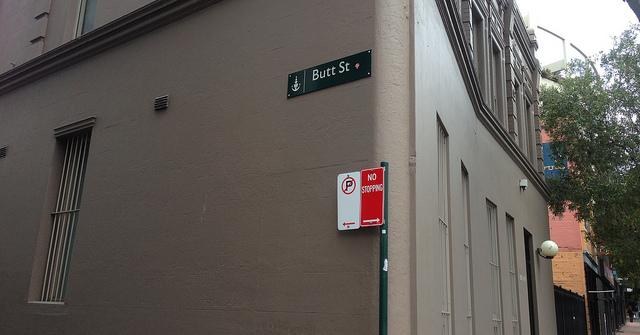What colors is the sign on the wall?
Give a very brief answer. Red and white. What are the letters on the building?
Give a very brief answer. Butt st. What street was this picture taken on?
Be succinct. Butt st. Is the building high?
Concise answer only. Yes. What are the words in the upper right?
Short answer required. Butt st. What do the red and white signs read?
Give a very brief answer. No parking. Is there a handrail?
Concise answer only. No. Is there a sidewalk?
Concise answer only. Yes. What color is the sign?
Keep it brief. Red and white. 